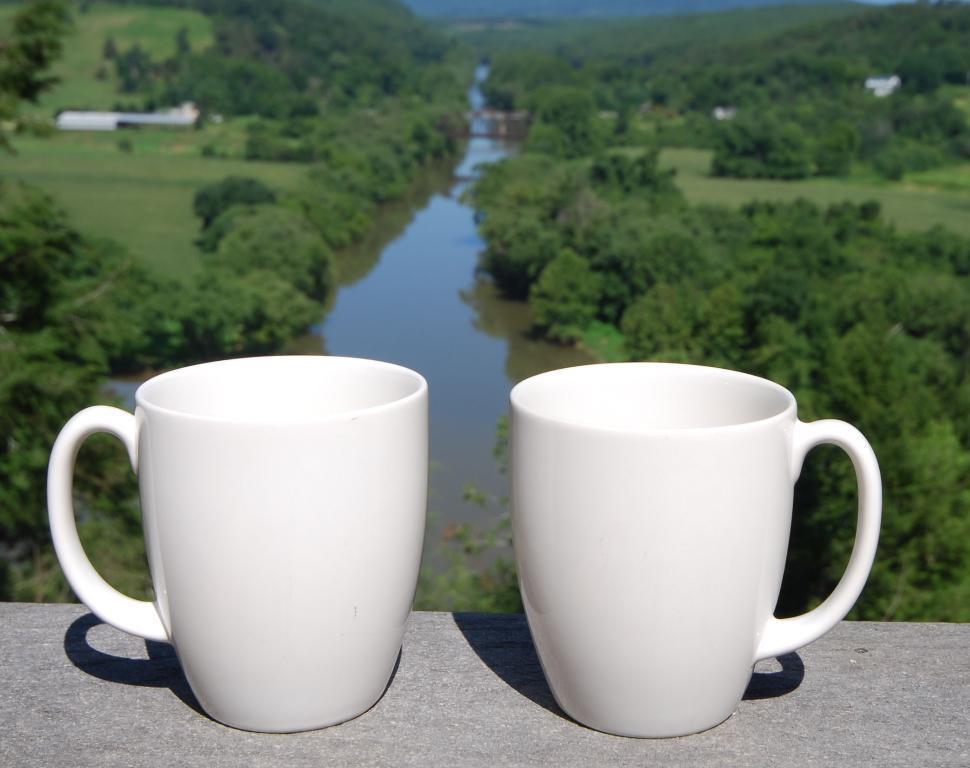Describe this image in one or two sentences. In this picture we can see couple of cups, in the background we can find water and few trees. 